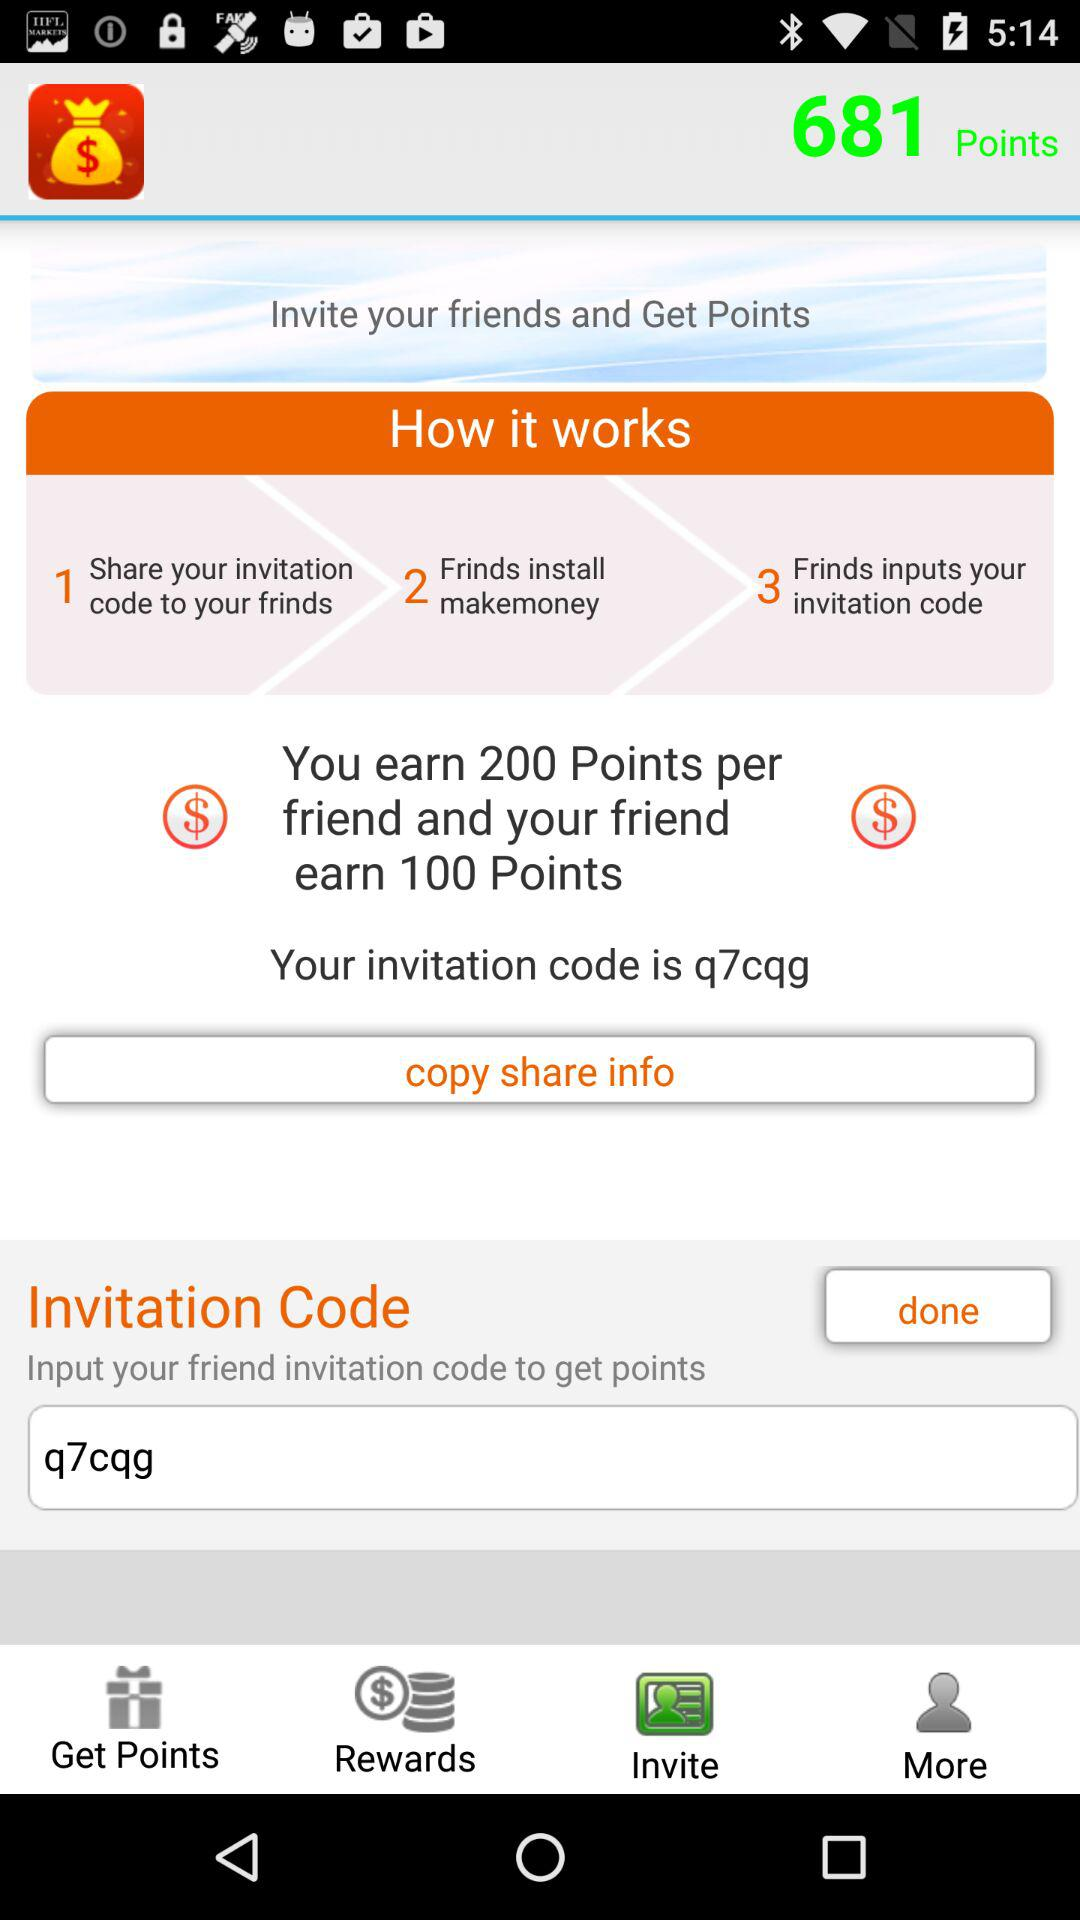What is the invitation code? The invitation code is "q7cqg". 